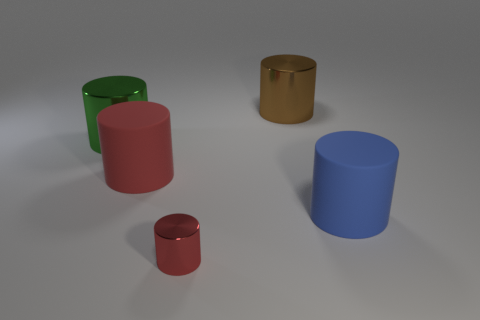Do the rubber cylinder that is to the left of the tiny red metal thing and the shiny thing in front of the large green shiny cylinder have the same color? Upon carefully examining the image, it appears that the rubber cylinder to the left of the tiny red metal object and the shiny object in front of the large green cylinder do not have the same color. The rubber cylinder exhibits a pinkish hue, while the shiny object in question has a golden sheen. 